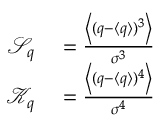<formula> <loc_0><loc_0><loc_500><loc_500>\begin{array} { r l } { \mathcal { S } _ { q } } & = \frac { \left \langle ( q - \langle q \rangle ) ^ { 3 } \right \rangle } { \sigma ^ { 3 } } } \\ { \mathcal { K } _ { q } } & = \frac { \left \langle ( q - \langle q \rangle ) ^ { 4 } \right \rangle } { \sigma ^ { 4 } } } \end{array}</formula> 